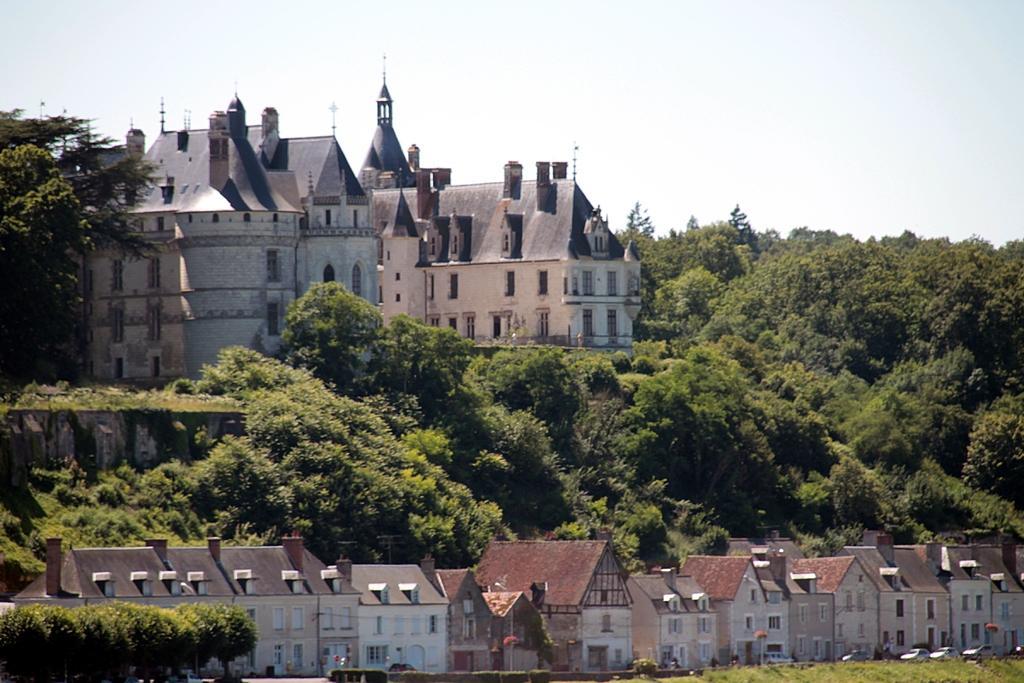Can you describe this image briefly? In this image we can see many buildings with windows. Also there are trees. In the background there is sky. 